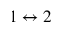<formula> <loc_0><loc_0><loc_500><loc_500>1 \leftrightarrow 2</formula> 